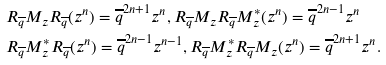Convert formula to latex. <formula><loc_0><loc_0><loc_500><loc_500>& R _ { \overline { q } } M _ { z } R _ { \overline { q } } ( z ^ { n } ) = \overline { q } ^ { 2 n + 1 } z ^ { n } , R _ { \overline { q } } M _ { z } R _ { \overline { q } } M _ { z } ^ { * } ( z ^ { n } ) = \overline { q } ^ { 2 n - 1 } z ^ { n } \\ & R _ { \overline { q } } M _ { z } ^ { * } R _ { \overline { q } } ( z ^ { n } ) = \overline { q } ^ { 2 n - 1 } z ^ { n - 1 } , R _ { \overline { q } } M _ { z } ^ { * } R _ { \overline { q } } M _ { z } ( z ^ { n } ) = \overline { q } ^ { 2 n + 1 } z ^ { n } .</formula> 